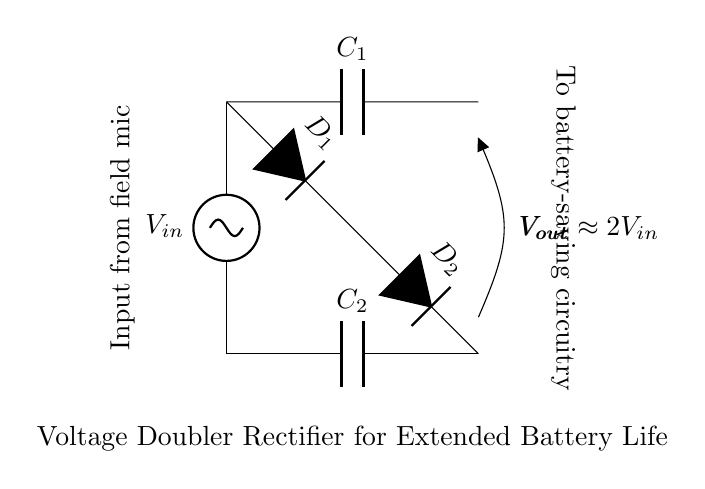What is the input voltage source labeled as? The input voltage source is labeled as V in, which is the voltage supplied for the circuit.
Answer: V in What do the diodes in the circuit do? The diodes, labeled as D1 and D2, are responsible for directing the current flow to ensure that the capacitors charge properly and the output voltage is doubled.
Answer: Direct current flow What is the role of capacitor C1? Capacitor C1 stores charge from the input source, contributing to the voltage doubling effect of the circuit.
Answer: Charge storage What is the output voltage approximately equal to? The output voltage is approximately equal to two times the input voltage, as indicated by the label V out, which is connected to the capacitors and diodes.
Answer: Approximately 2 V in How many capacitors are in the circuit? There are two capacitors in the circuit, labeled C1 and C2, which are essential for the voltage doubler function.
Answer: Two What is the overall purpose of this circuit? The overall purpose of this circuit is to double the voltage from the input source to extend the battery life for field recording devices.
Answer: Extend battery life Why is this circuit referred to as a voltage doubler rectifier? This circuit is called a voltage doubler rectifier because it rectifies the alternating current to direct current while also doubling the voltage level for efficiency.
Answer: Voltage doubler rectifier 